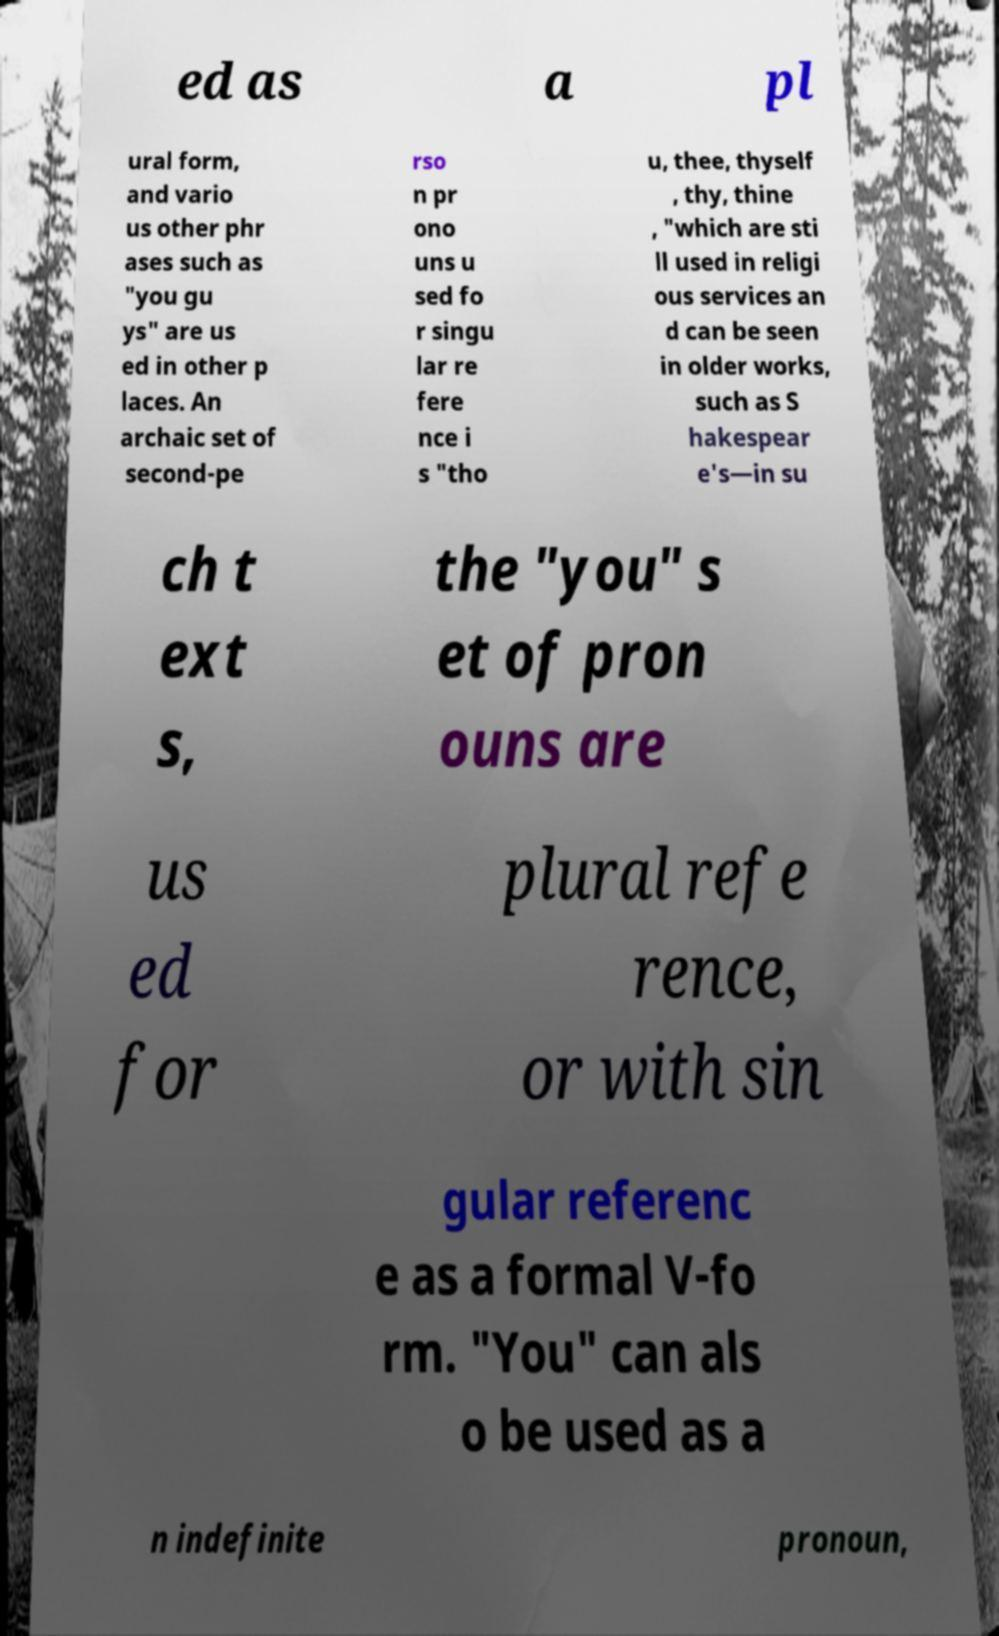I need the written content from this picture converted into text. Can you do that? ed as a pl ural form, and vario us other phr ases such as "you gu ys" are us ed in other p laces. An archaic set of second-pe rso n pr ono uns u sed fo r singu lar re fere nce i s "tho u, thee, thyself , thy, thine , "which are sti ll used in religi ous services an d can be seen in older works, such as S hakespear e's—in su ch t ext s, the "you" s et of pron ouns are us ed for plural refe rence, or with sin gular referenc e as a formal V-fo rm. "You" can als o be used as a n indefinite pronoun, 